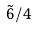<formula> <loc_0><loc_0><loc_500><loc_500>\tilde { 6 } / 4</formula> 